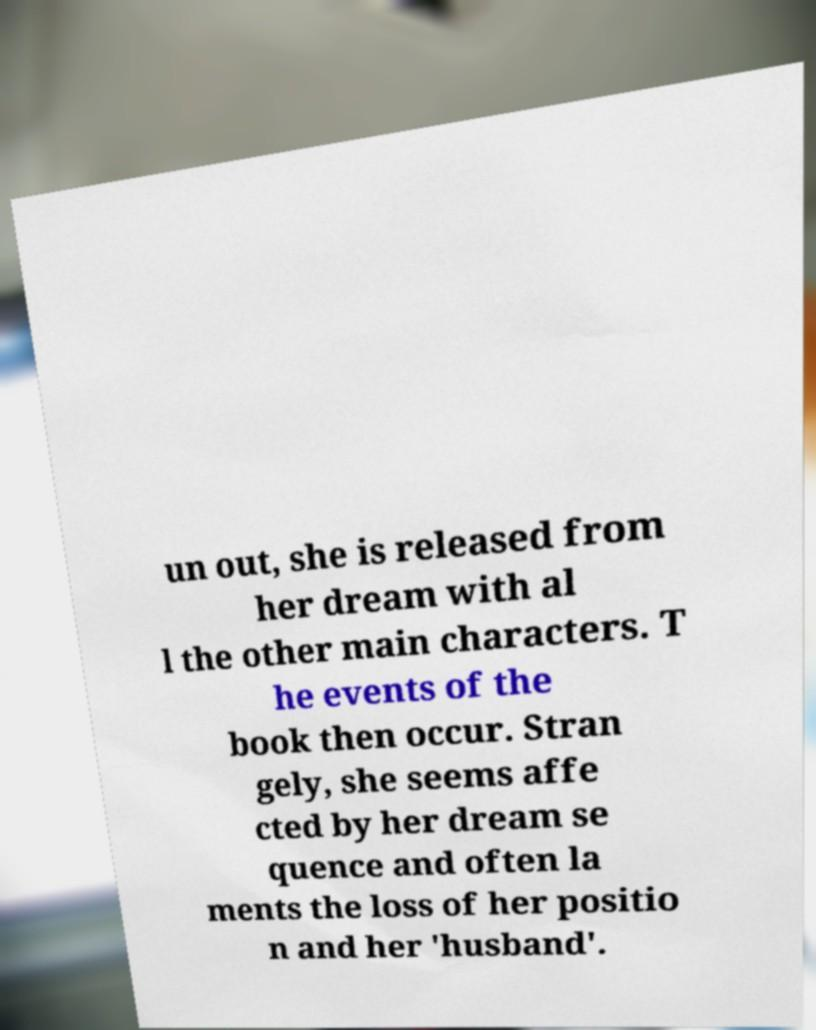Could you extract and type out the text from this image? un out, she is released from her dream with al l the other main characters. T he events of the book then occur. Stran gely, she seems affe cted by her dream se quence and often la ments the loss of her positio n and her 'husband'. 